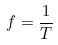Convert formula to latex. <formula><loc_0><loc_0><loc_500><loc_500>f = \frac { 1 } { T }</formula> 